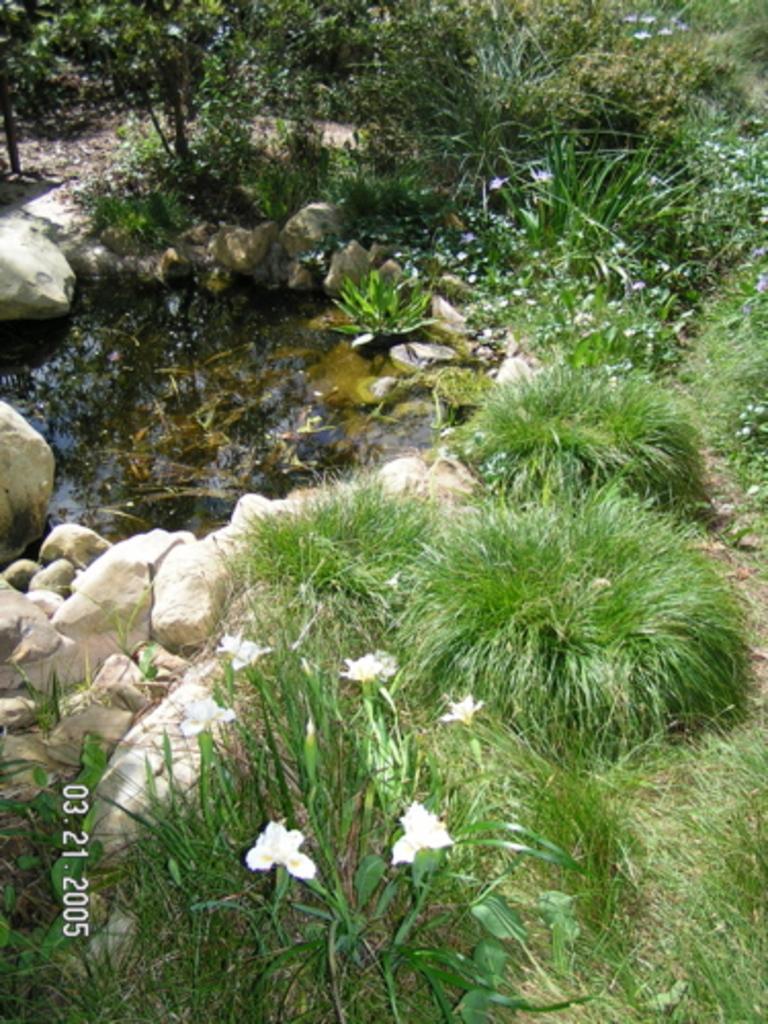Please provide a concise description of this image. In this image there are small plants and grass at the bottom. There are small rocks on the left corner. There is water and small rocks in the foreground. There are plants in the background. 